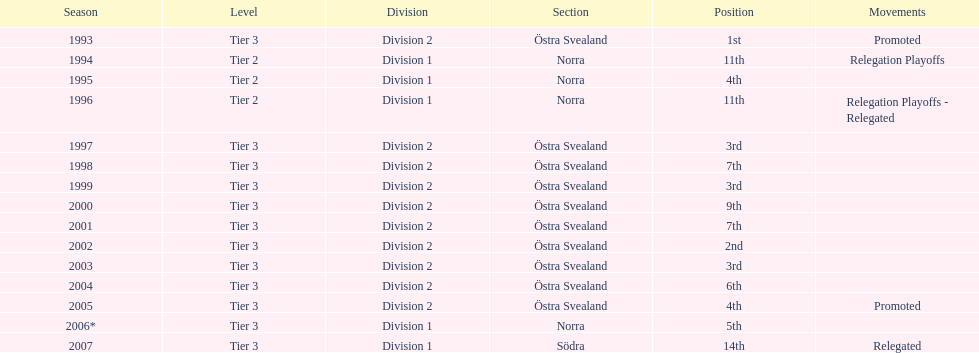In total, how many times were they promoted? 2. 